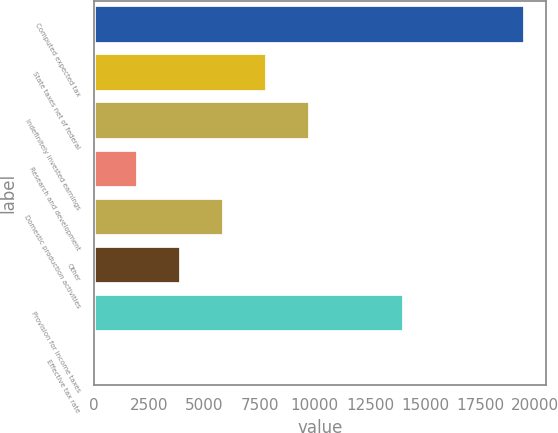Convert chart. <chart><loc_0><loc_0><loc_500><loc_500><bar_chart><fcel>Computed expected tax<fcel>State taxes net of federal<fcel>Indefinitely invested earnings<fcel>Research and development<fcel>Domestic production activities<fcel>Other<fcel>Provision for income taxes<fcel>Effective tax rate<nl><fcel>19517<fcel>7821.92<fcel>9771.1<fcel>1974.38<fcel>5872.74<fcel>3923.56<fcel>14030<fcel>25.2<nl></chart> 